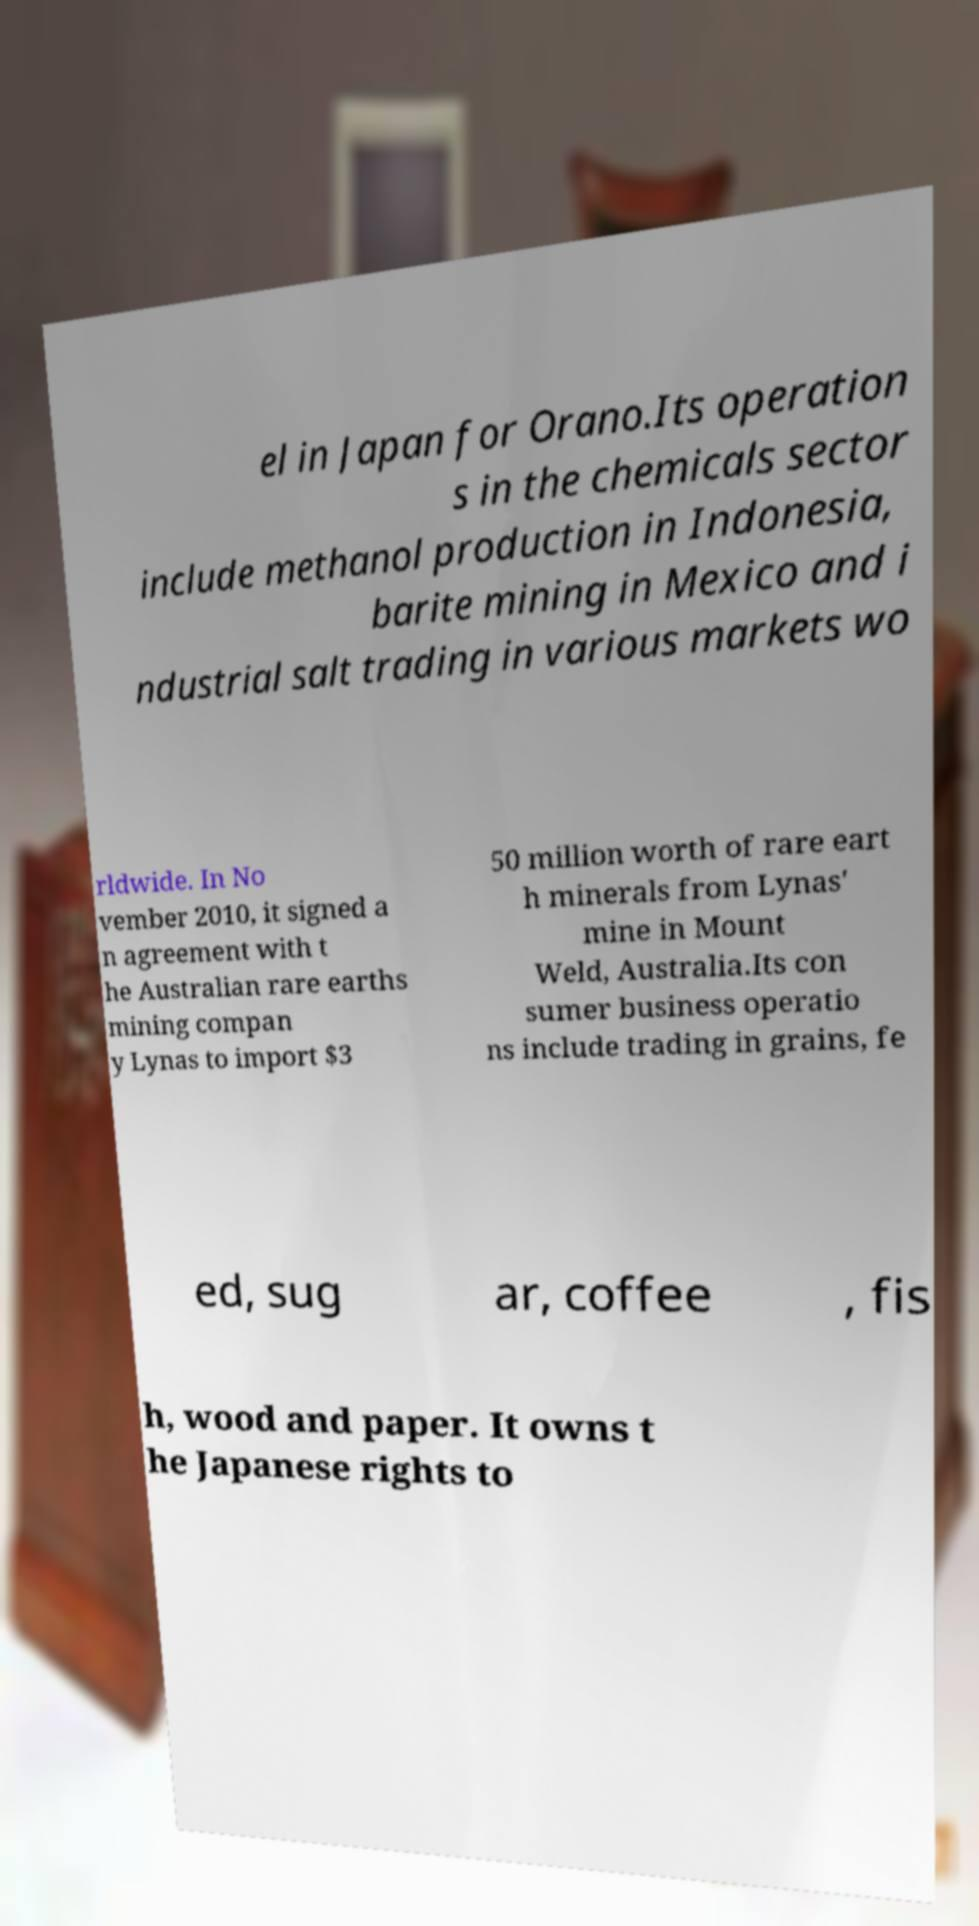Could you extract and type out the text from this image? el in Japan for Orano.Its operation s in the chemicals sector include methanol production in Indonesia, barite mining in Mexico and i ndustrial salt trading in various markets wo rldwide. In No vember 2010, it signed a n agreement with t he Australian rare earths mining compan y Lynas to import $3 50 million worth of rare eart h minerals from Lynas' mine in Mount Weld, Australia.Its con sumer business operatio ns include trading in grains, fe ed, sug ar, coffee , fis h, wood and paper. It owns t he Japanese rights to 